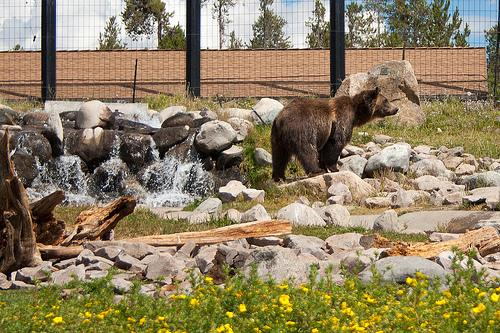Provide a crisp, one-sentence summary of the scene in the photograph. A brown bear roams in its zoo enclosure featuring rocks and a small waterfall, with yellow flowers visible outside the fenced area. Provide a brief description of the primary focus in the photo. A large brown bear is walking across rocks away from a small stone waterfall in an enclosure. Imagine you are describing the photo to someone who can't see it, be detailed and concise at the same time. There's a large brown bear walking on rocks in its zoo enclosure, with diverse rock sizes, a small waterfall, and a field of yellow flowers visible through a black metal fence. In a short sentence, mention the key subject in the image and its environment. The brown bear stands out in its enclosure filled with rocks, a small waterfall, and a black metal fence near yellow flowers. Narrate a scene that you perceive in the photograph. In a zoo enclosure, a brown bear ambles across an area filled with rocks and a small waterfall, while a field of bright yellow flowers lies just outside next to a black metal fence. Using simple language, describe the main elements in the photograph. A photo shows a big brown bear walking in a zoo cage with rocks, a waterfall, and yellow flowers outside the fence. Concisely depict the natural elements found in the image. The image displays a brown bear amidst an enclosure with rocks, a small waterfall, a field of yellow flowers, and a black metal fence. Imagine yourself in the image, and describe the surroundings you notice. Standing in a zoo enclosure, I'm observing a brown bear walking among various sized rocks and a small waterfall, while a field of yellow flowers is visible beyond the black metal fence. List the primary objects and their descriptions in the given image. Objects include a brown bear standing in an enclosure, black metal fence with wooden posts, yellow buttercup flowers field, various sized rocks, and a stone waterfall. Compose a brief account of the environment where the central subject is situated. The main subject, a brown bear, is situated in a zoo enclosure with rocks, a stone waterfall, and a black metal fence, with a field of yellow flowers nearby. 